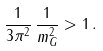<formula> <loc_0><loc_0><loc_500><loc_500>\frac { 1 } { 3 \pi ^ { 2 } } \, \frac { 1 } { m _ { G } ^ { 2 } } > 1 \, .</formula> 